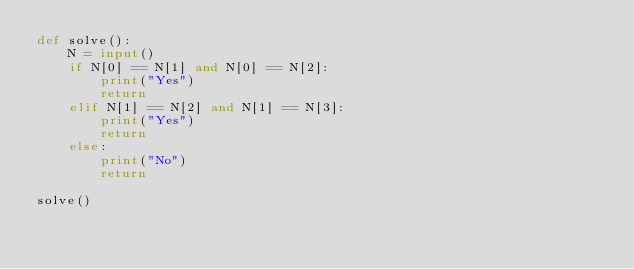<code> <loc_0><loc_0><loc_500><loc_500><_Python_>def solve():
    N = input()
    if N[0] == N[1] and N[0] == N[2]:
        print("Yes")
        return
    elif N[1] == N[2] and N[1] == N[3]:
        print("Yes")
        return
    else:
        print("No")
        return

solve()
</code> 